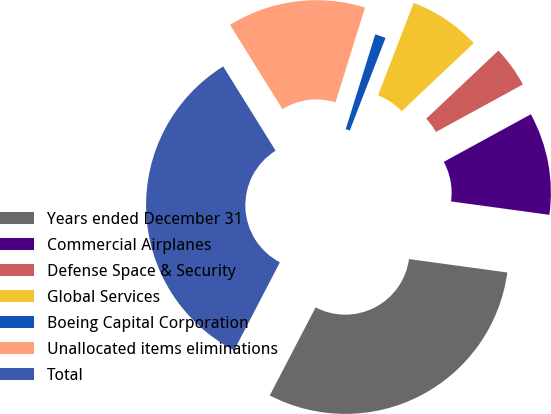<chart> <loc_0><loc_0><loc_500><loc_500><pie_chart><fcel>Years ended December 31<fcel>Commercial Airplanes<fcel>Defense Space & Security<fcel>Global Services<fcel>Boeing Capital Corporation<fcel>Unallocated items eliminations<fcel>Total<nl><fcel>30.48%<fcel>10.12%<fcel>4.08%<fcel>7.1%<fcel>1.06%<fcel>13.66%<fcel>33.5%<nl></chart> 